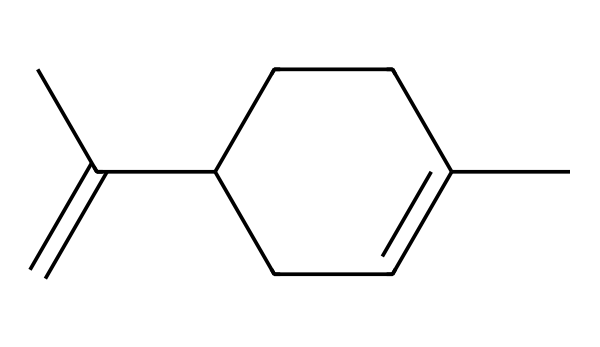What is the molecular formula of limonene? To determine the molecular formula, count the number of carbon (C) and hydrogen (H) atoms in the SMILES representation. The structure has 10 carbon atoms and 16 hydrogen atoms, leading to the formula C10H16.
Answer: C10H16 How many rings are present in the molecular structure of limonene? In the SMILES representation, the 'C1=CCC' notation indicates a cyclic structure involving a ring. The number '1' indicates the start and end of a ring. Since there is only one such number, there is one ring present.
Answer: one What type of compound is limonene primarily classified as? Limonene is described as a monoterpene, which is a type of aliphatic compound mainly derived from plants. Its structure shows it consists of a simple carbon framework typical of terpenes.
Answer: monoterpene What functional group is inferred from the double bond in limonene? The double bond present in the molecular structure (C=C) indicates that limonene contains an alkene functional group, characterized by the presence of carbon-carbon double bonds.
Answer: alkene What property does the structure of limonene suggest about its volatility? The aliphatic nature and smaller size of the molecule suggest that limonene is likely to be volatile, as lighter aliphatic compounds tend to evaporate more easily due to lower molecular weights and weaker intermolecular forces.
Answer: volatile How many pi bonds are present in the molecular structure? The double bond between carbon atoms contributes one pi bond. Since there is only one double bond in the structure (C=C), there is a total of one pi bond present.
Answer: one 